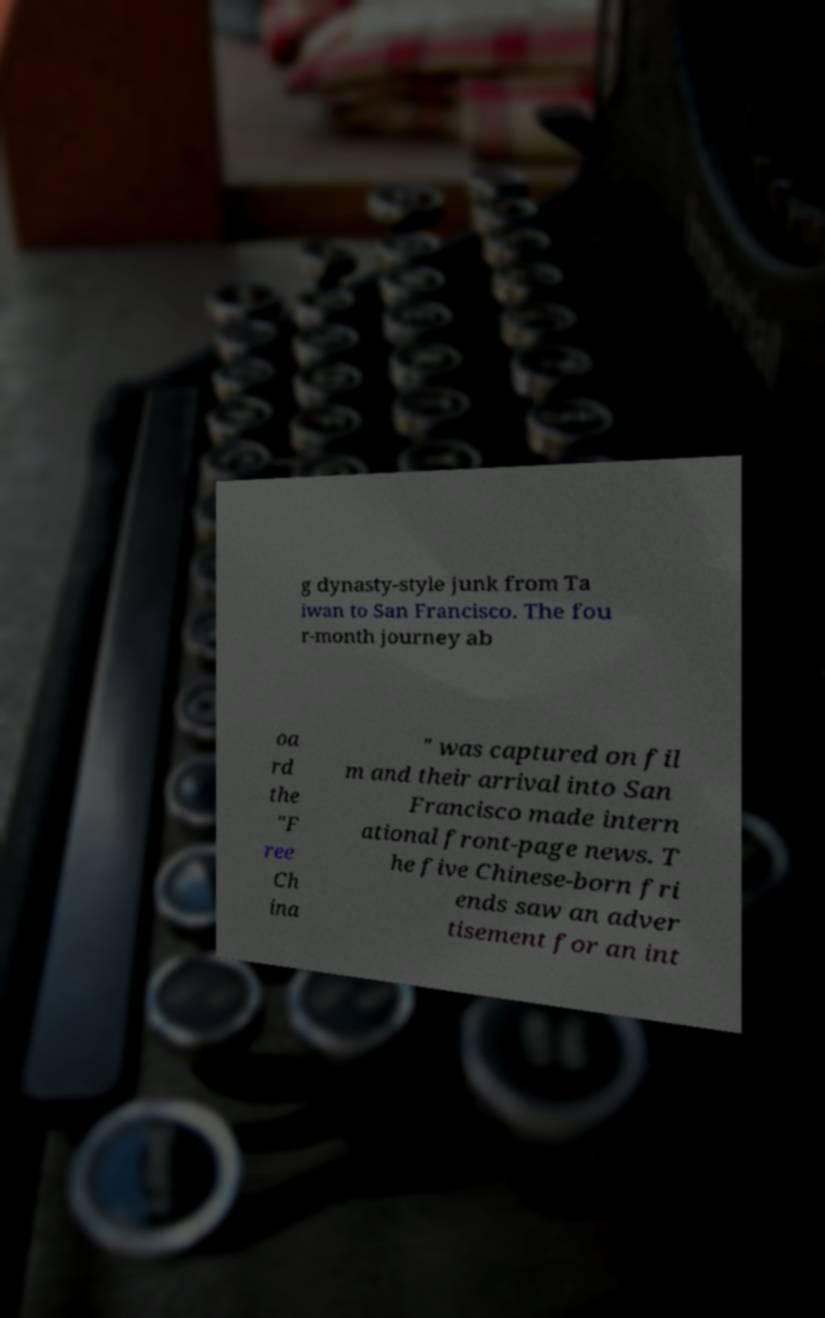Could you assist in decoding the text presented in this image and type it out clearly? g dynasty-style junk from Ta iwan to San Francisco. The fou r-month journey ab oa rd the "F ree Ch ina " was captured on fil m and their arrival into San Francisco made intern ational front-page news. T he five Chinese-born fri ends saw an adver tisement for an int 